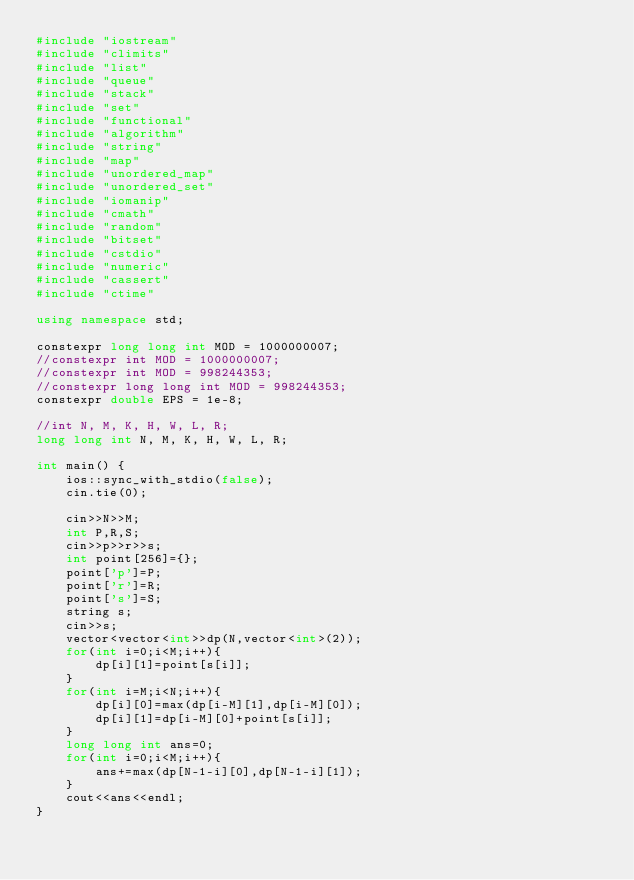<code> <loc_0><loc_0><loc_500><loc_500><_C++_>#include "iostream"
#include "climits"
#include "list"
#include "queue"
#include "stack"
#include "set"
#include "functional"
#include "algorithm"
#include "string"
#include "map"
#include "unordered_map"
#include "unordered_set"
#include "iomanip"
#include "cmath"
#include "random"
#include "bitset"
#include "cstdio"
#include "numeric"
#include "cassert"
#include "ctime"

using namespace std;

constexpr long long int MOD = 1000000007;
//constexpr int MOD = 1000000007;
//constexpr int MOD = 998244353;
//constexpr long long int MOD = 998244353;
constexpr double EPS = 1e-8;

//int N, M, K, H, W, L, R;
long long int N, M, K, H, W, L, R;

int main() {
	ios::sync_with_stdio(false);
	cin.tie(0);
	
	cin>>N>>M;
	int P,R,S;
	cin>>p>>r>>s;
	int point[256]={};
	point['p']=P;
	point['r']=R;
	point['s']=S;
	string s;
	cin>>s;
	vector<vector<int>>dp(N,vector<int>(2));
	for(int i=0;i<M;i++){
		dp[i][1]=point[s[i]];
	}
	for(int i=M;i<N;i++){
		dp[i][0]=max(dp[i-M][1],dp[i-M][0]);
		dp[i][1]=dp[i-M][0]+point[s[i]];
	}
	long long int ans=0;
	for(int i=0;i<M;i++){
		ans+=max(dp[N-1-i][0],dp[N-1-i][1]);
	}
	cout<<ans<<endl;
}</code> 